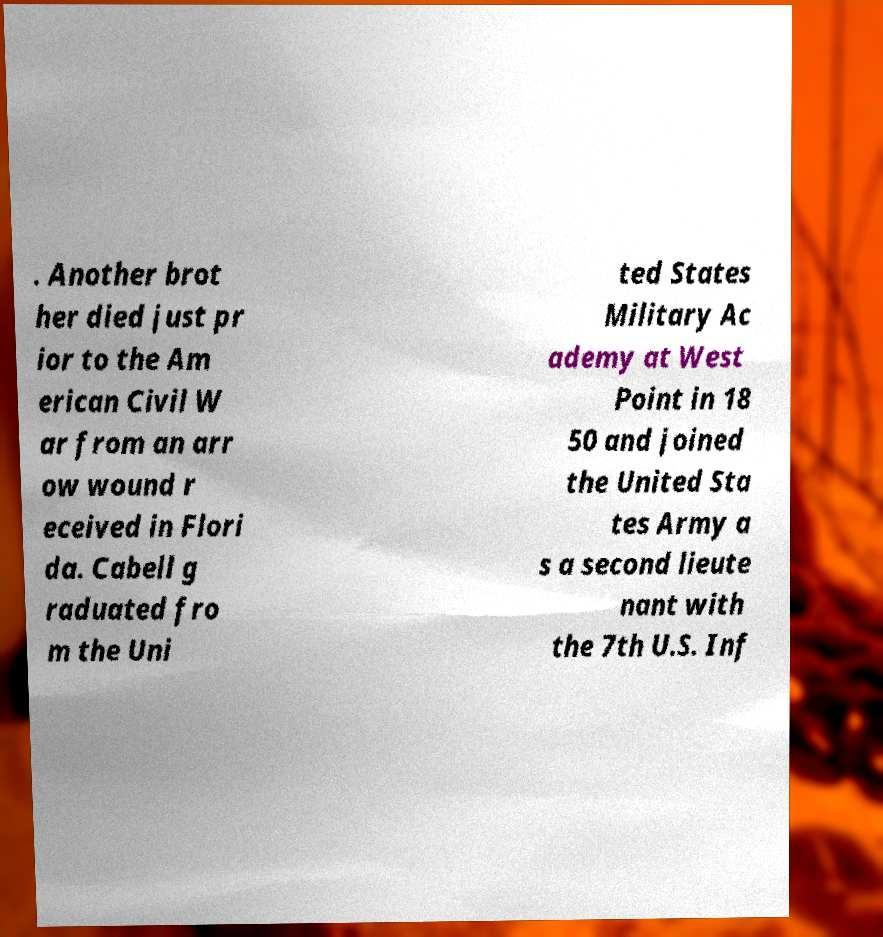Please identify and transcribe the text found in this image. . Another brot her died just pr ior to the Am erican Civil W ar from an arr ow wound r eceived in Flori da. Cabell g raduated fro m the Uni ted States Military Ac ademy at West Point in 18 50 and joined the United Sta tes Army a s a second lieute nant with the 7th U.S. Inf 